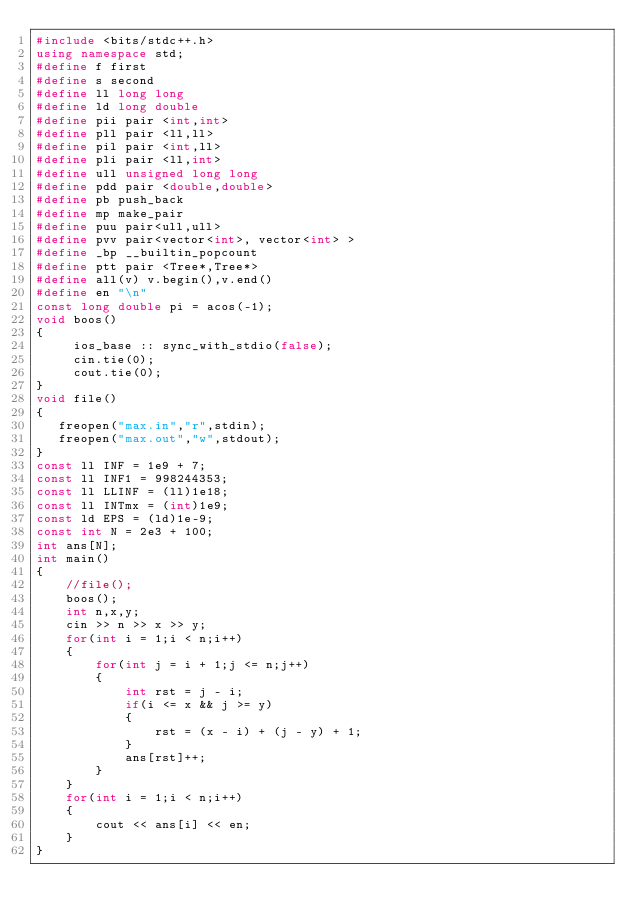<code> <loc_0><loc_0><loc_500><loc_500><_C++_>#include <bits/stdc++.h>
using namespace std;
#define f first
#define s second
#define ll long long
#define ld long double
#define pii pair <int,int>
#define pll pair <ll,ll>
#define pil pair <int,ll>
#define pli pair <ll,int>
#define ull unsigned long long
#define pdd pair <double,double>
#define pb push_back
#define mp make_pair
#define puu pair<ull,ull>
#define pvv pair<vector<int>, vector<int> >
#define _bp __builtin_popcount
#define ptt pair <Tree*,Tree*>
#define all(v) v.begin(),v.end()
#define en "\n"
const long double pi = acos(-1);
void boos()
{
     ios_base :: sync_with_stdio(false);
     cin.tie(0);
     cout.tie(0);
}
void file()
{
   freopen("max.in","r",stdin);
   freopen("max.out","w",stdout);
}
const ll INF = 1e9 + 7;
const ll INF1 = 998244353;
const ll LLINF = (ll)1e18;
const ll INTmx = (int)1e9;
const ld EPS = (ld)1e-9;
const int N = 2e3 + 100;
int ans[N];
int main()
{
    //file();
    boos();
    int n,x,y;
    cin >> n >> x >> y;
    for(int i = 1;i < n;i++)
    {
    	for(int j = i + 1;j <= n;j++)
    	{
    		int rst = j - i;
    		if(i <= x && j >= y)
    		{
    			rst = (x - i) + (j - y) + 1;
			}
			ans[rst]++;
		}
	}
	for(int i = 1;i < n;i++)
	{
		cout << ans[i] << en;
	}
}</code> 